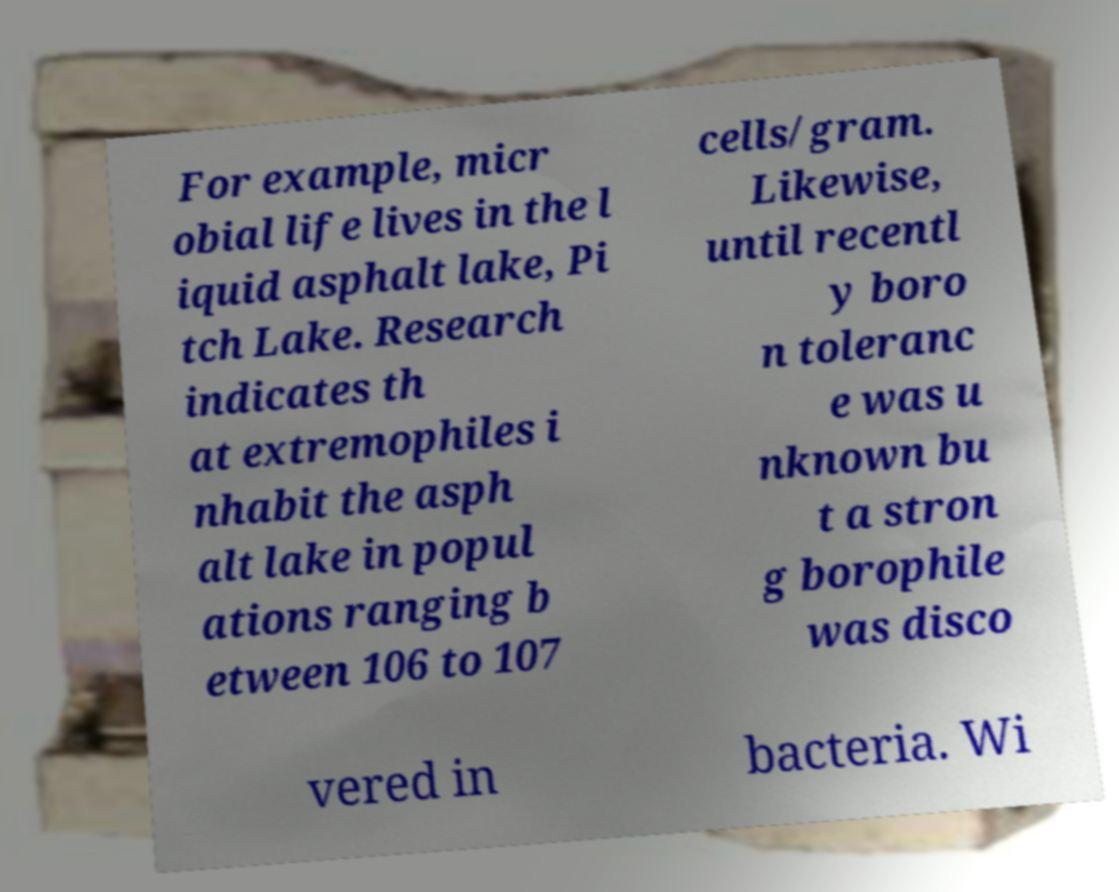Could you extract and type out the text from this image? For example, micr obial life lives in the l iquid asphalt lake, Pi tch Lake. Research indicates th at extremophiles i nhabit the asph alt lake in popul ations ranging b etween 106 to 107 cells/gram. Likewise, until recentl y boro n toleranc e was u nknown bu t a stron g borophile was disco vered in bacteria. Wi 